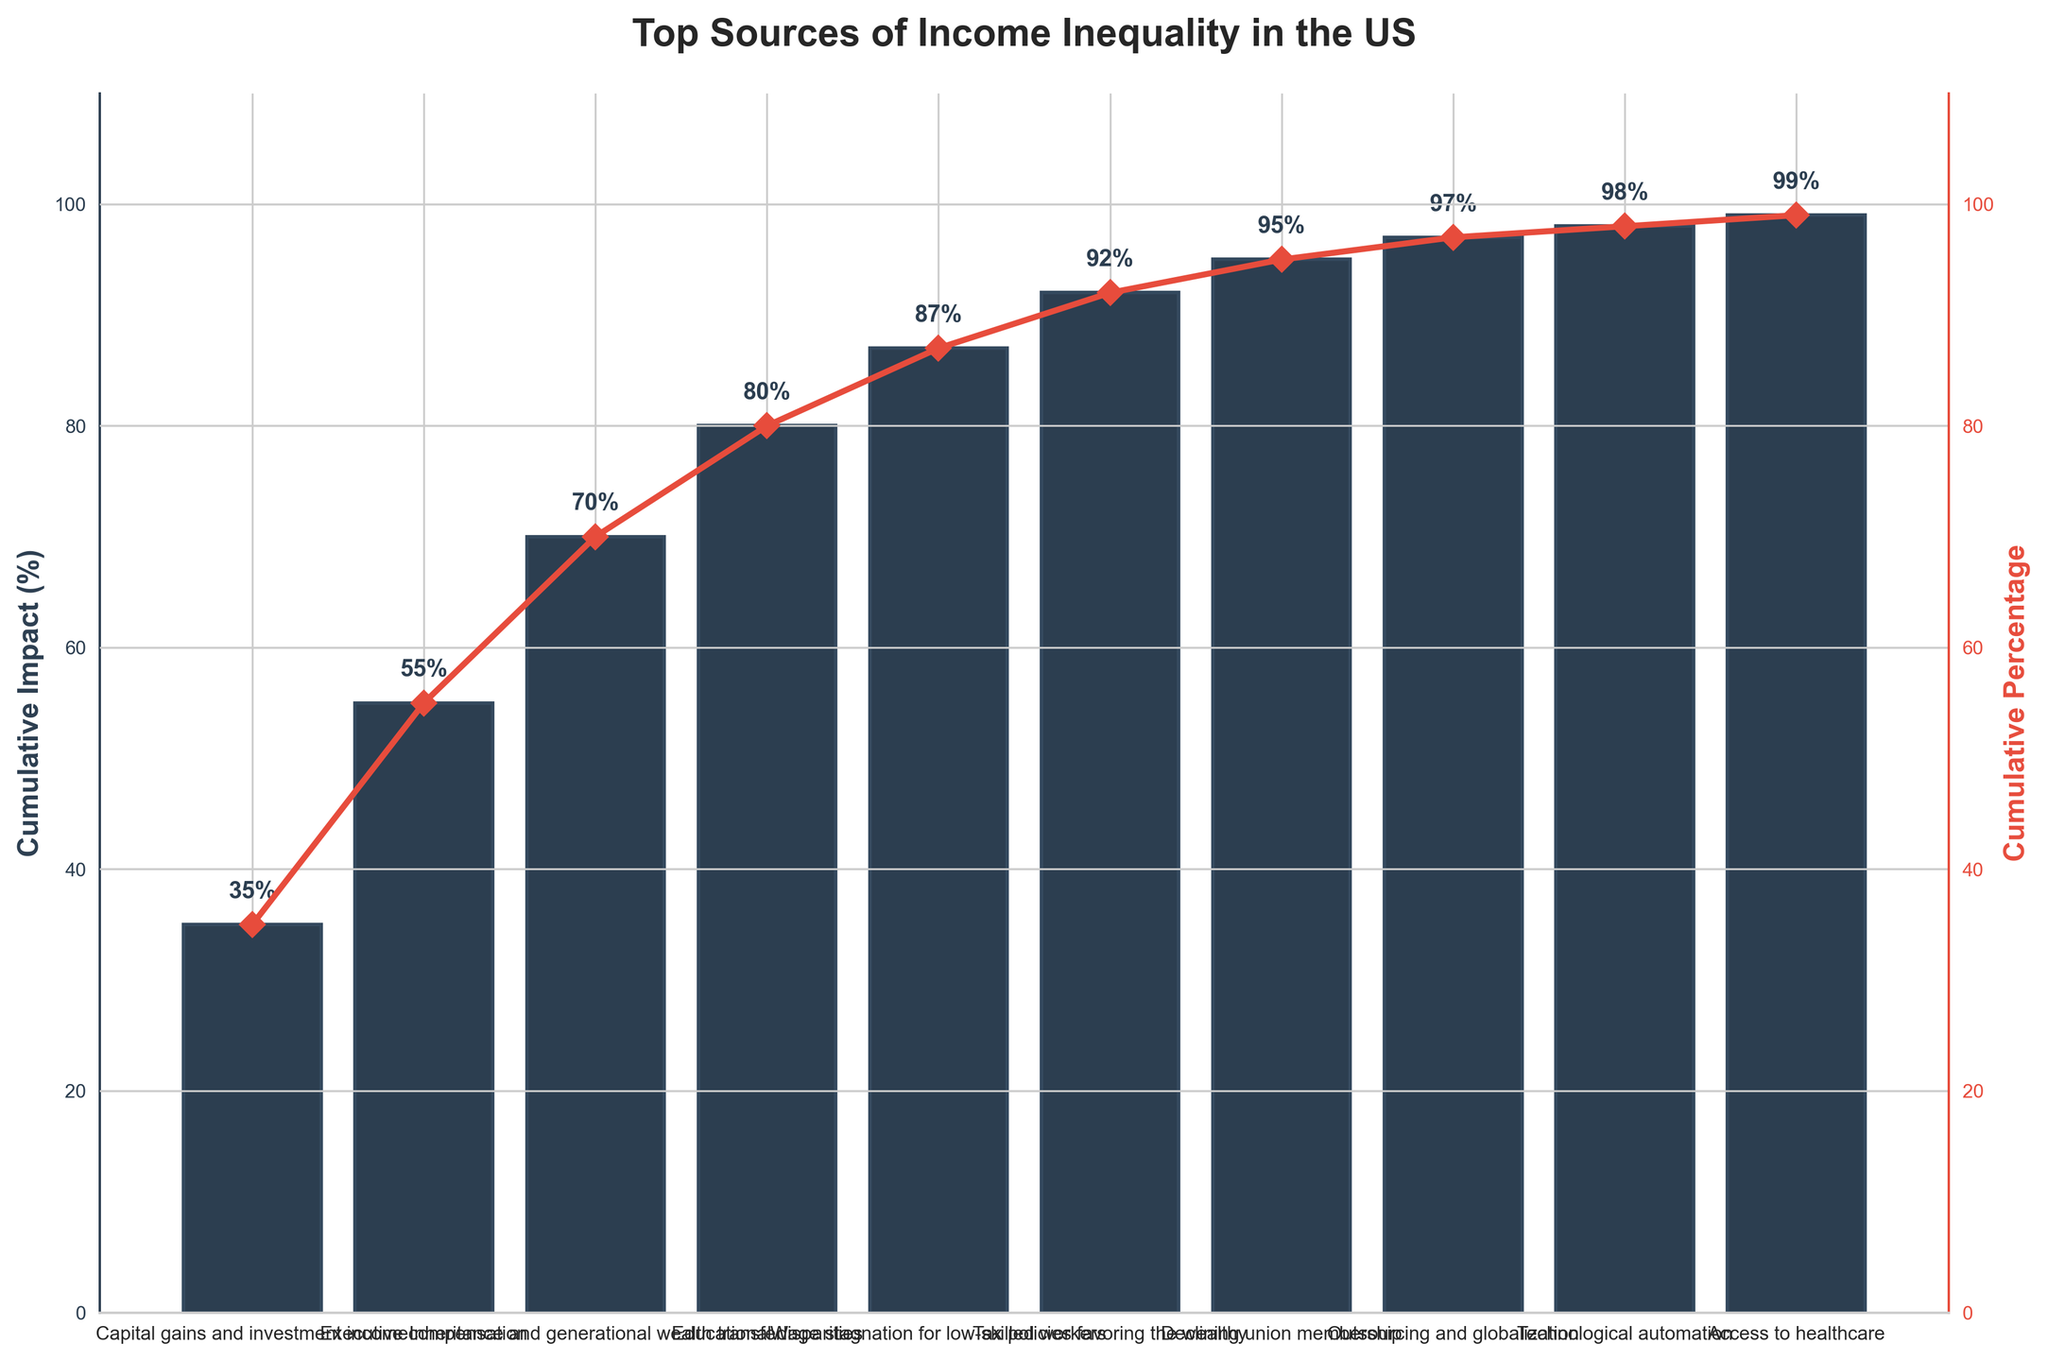What's the highest-impact source of income inequality in the US according to the figure? The Pareto chart shows that 'Capital gains and investment income' has the largest cumulative impact, reaching 35%. This is evidenced by the highest bar and its corresponding data point.
Answer: Capital gains and investment income What impact does 'Technological automation' have on income inequality? 'Technological automation' has a cumulative impact percentage of 98%, as displayed by the height of its bar on the chart.
Answer: 98% How many sources are listed in the figure as contributing to income inequality? There are a total of 10 sources listed, observable by counting the bars or labels on the x-axis of the Pareto chart.
Answer: 10 What is the cumulative impact percentage of 'Educational disparities'? The chart shows that 'Educational disparities' have a cumulative impact percentage of 80%. This is displayed both by the height of the bar and its corresponding data point.
Answer: 80% Which source has a higher impact on income inequality, 'Declining union membership' or 'Wage stagnation for low-skilled workers'? 'Wage stagnation for low-skilled workers' has a cumulative impact percentage of 87%, which is higher than 'Declining union membership' at 95%.
Answer: Wage stagnation for low-skilled workers What's the difference in cumulative impact between 'Inheritance and generational wealth transfer' and 'Tax policies favoring the wealthy'? 'Inheritance and generational wealth transfer' has a cumulative impact of 70% while 'Tax policies favoring the wealthy' have 92%, making the difference 92% - 70% = 22%.
Answer: 22% Between which two sources does the cumulative impact percentage jump the most? The largest jump is observed between 'Capital gains and investment income' (35%) and 'Executive compensation' (55%), a difference of 20%. Other differences are smaller.
Answer: Capital gains and investment income and Executive compensation What is the cumulative impact on income inequality of the sources with the lowest impacts listed in the figure? The sources with impacts below 90% are 'Declining union membership', 'Outsourcing and globalization', 'Technological automation', and 'Access to healthcare'. Their impacts are 95%, 97%, 98%, and 99%, respectively. Cumulatively, their impact is 95% + 2% + 1% + 1% = 99%.
Answer: 99% What's the average cumulative impact percentage of the sources listed in the figure? The cumulative impact percentages are: 35, 55, 70, 80, 87, 92, 95, 97, 98, 99. Summing these up gives 808, and dividing by the number of sources (10) yields an average of 808/10 = 80.8%.
Answer: 80.8% Which bar reaches the second highest point on the chart? The second highest bar on the chart represents 'Technological automation', which reaches 98%.
Answer: Technological automation 